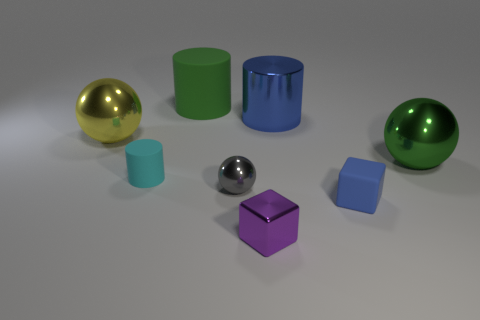How many other things are there of the same shape as the big matte object?
Keep it short and to the point. 2. There is a metallic object that is to the left of the tiny gray shiny object; is there a tiny purple metallic thing on the right side of it?
Your answer should be compact. Yes. What number of matte things are tiny cyan cylinders or big green things?
Offer a terse response. 2. There is a object that is in front of the green metallic object and to the left of the green rubber thing; what is its material?
Your answer should be very brief. Rubber. Are there any tiny cyan cylinders that are in front of the green object that is behind the big metal ball on the right side of the big yellow metallic thing?
Keep it short and to the point. Yes. What shape is the large blue object that is the same material as the purple object?
Provide a short and direct response. Cylinder. Is the number of tiny metallic things that are behind the blue metallic object less than the number of blue matte objects that are behind the green shiny object?
Offer a very short reply. No. What number of large objects are either yellow metal cylinders or cyan matte cylinders?
Offer a terse response. 0. There is a small rubber thing that is in front of the cyan matte object; does it have the same shape as the green object to the left of the tiny purple cube?
Make the answer very short. No. There is a shiny thing that is right of the tiny matte object that is to the right of the matte thing to the left of the large matte cylinder; how big is it?
Your answer should be compact. Large. 